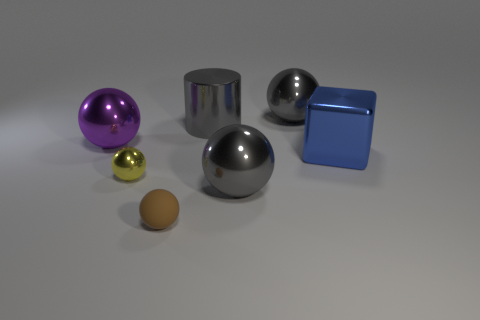Subtract all purple spheres. How many spheres are left? 4 Subtract all blue spheres. Subtract all brown cubes. How many spheres are left? 5 Add 2 gray cylinders. How many objects exist? 9 Subtract all balls. How many objects are left? 2 Subtract all small matte balls. Subtract all gray spheres. How many objects are left? 4 Add 2 tiny yellow metallic things. How many tiny yellow metallic things are left? 3 Add 6 gray objects. How many gray objects exist? 9 Subtract 0 blue spheres. How many objects are left? 7 